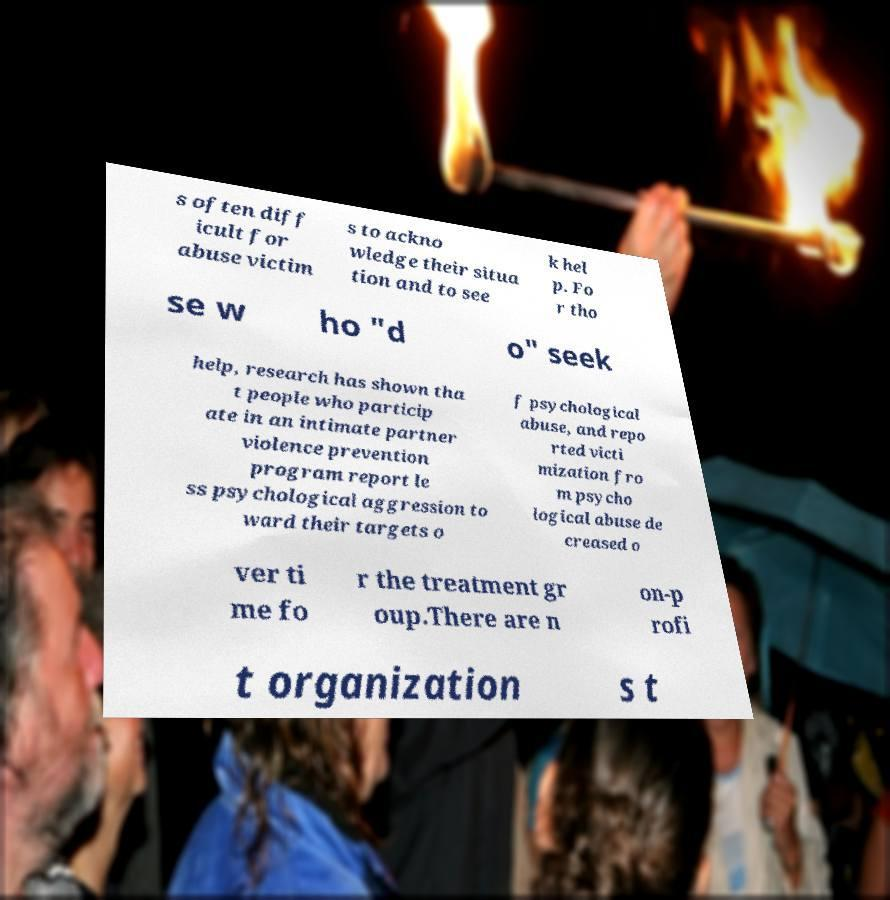What messages or text are displayed in this image? I need them in a readable, typed format. s often diff icult for abuse victim s to ackno wledge their situa tion and to see k hel p. Fo r tho se w ho "d o" seek help, research has shown tha t people who particip ate in an intimate partner violence prevention program report le ss psychological aggression to ward their targets o f psychological abuse, and repo rted victi mization fro m psycho logical abuse de creased o ver ti me fo r the treatment gr oup.There are n on-p rofi t organization s t 